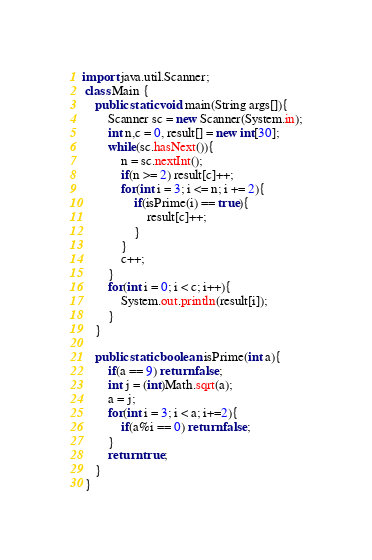Convert code to text. <code><loc_0><loc_0><loc_500><loc_500><_Java_>
import java.util.Scanner;
 class Main {
	public static void main(String args[]){
		Scanner sc = new Scanner(System.in);
		int n,c = 0, result[] = new int[30];
		while(sc.hasNext()){
			n = sc.nextInt();
			if(n >= 2) result[c]++;
			for(int i = 3; i <= n; i += 2){
				if(isPrime(i) == true){
					result[c]++;
				}
			}
			c++;
		}
		for(int i = 0; i < c; i++){
			System.out.println(result[i]);
		}
	}
	
	public static boolean isPrime(int a){
		if(a == 9) return false;
		int j = (int)Math.sqrt(a);
		a = j;
		for(int i = 3; i < a; i+=2){
			if(a%i == 0) return false;
		}
		return true;
	}
 }</code> 